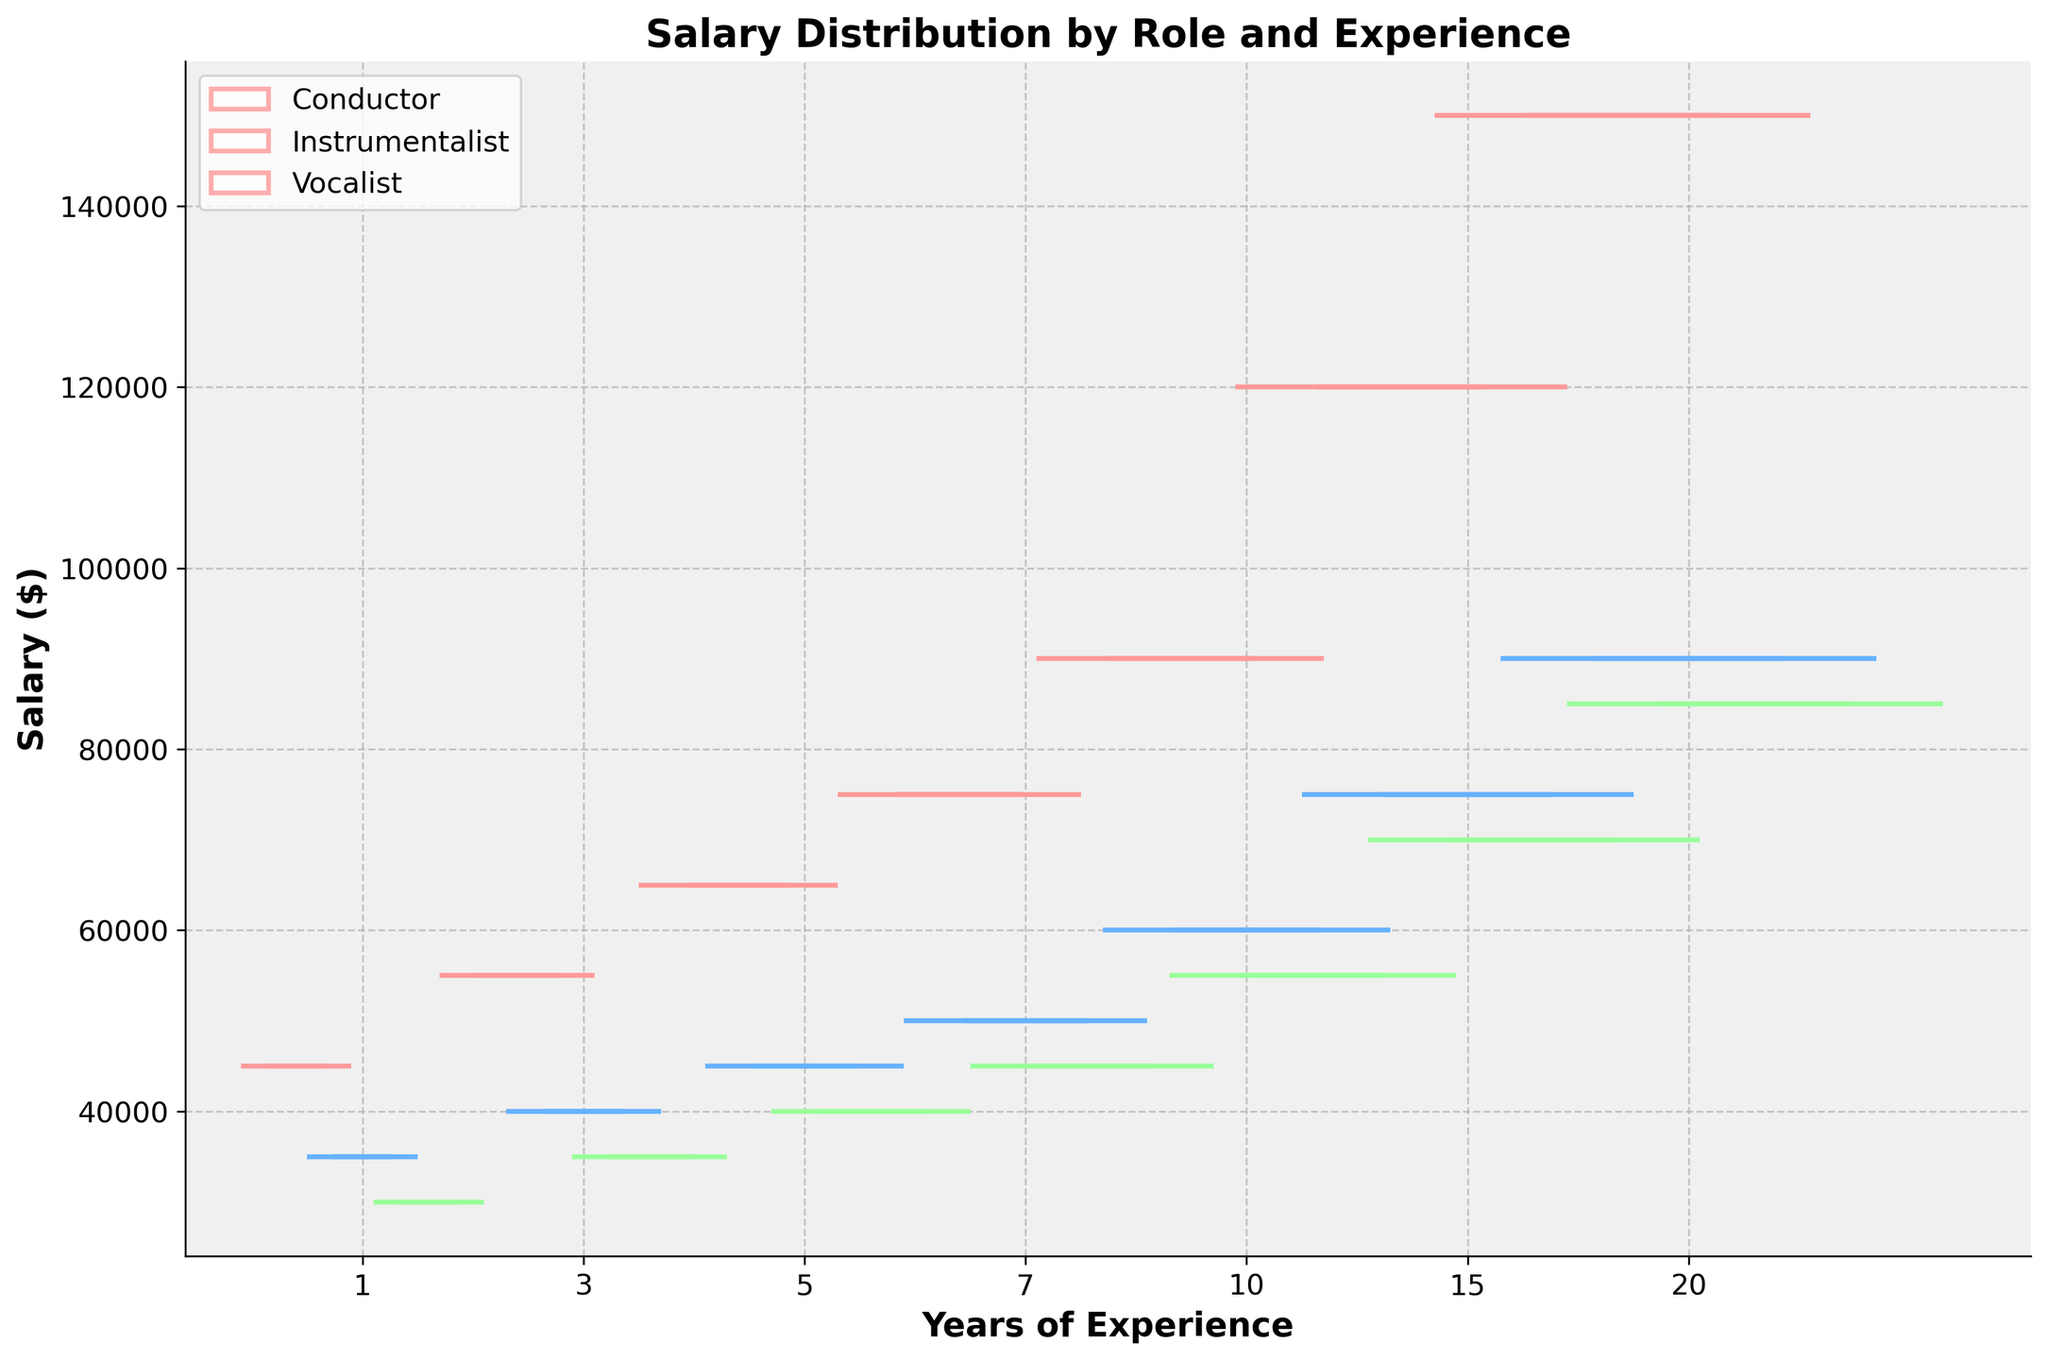What's the title of the figure? The title of the figure is written at the top and provides an overview of what the figure is about. By looking at the top of the figure, you can see the title clearly.
Answer: Salary Distribution by Role and Experience Which role has the highest median salary for 20 years of experience? To find the highest median salary for 20 years of experience, look at the boxes for each role at the 20-year mark. The one with the highest line in the middle of the box indicates the highest median salary.
Answer: Conductor What is the trend of the median salary for conductors as experience years increase? Observe the median lines (the horizontal lines inside the boxes) for conductors across different experience years. The trend shows how these medians change as the years of experience increase.
Answer: Increasing How does the salary range for vocalists compare at 10 and 15 years of experience? To compare the salary ranges, look at the box plots for vocalists at 10 and 15 years. The height of the boxes shows the range. A taller box means a wider range.
Answer: The range is wider at 15 years than at 10 years Which role shows the most significant increase in median salary from 1 year to 20 years of experience? For this, check the median lines for each role at 1 year and then at 20 years. Calculate the difference for each role and determine which has the largest increase.
Answer: Conductor How do the widths of the boxes change with experience years? The widths of the boxes represent the number of data points or variability. Look at how the widths vary as you move from 1 year to 20 years of experience to determine if they get wider or narrower.
Answer: Generally increase Which experience year has the most number of data points? The width of the box corresponds to the number of data points for that experience year. The year with the widest boxes has the most data points.
Answer: 20 years Do instrumentalists have a higher median salary than vocalists at 7 years of experience? Compare the medians (the lines inside the boxes) of the box plots for instrumentalists and vocalists at the 7-year mark to see which is higher.
Answer: Yes What is the color used for conductors in the figure? Each role in the figure is represented by a different color. By looking at the boxes for conductors, you can identify their color.
Answer: Red (or a similar shade) Are there any outliers shown in the box plots? Outliers are usually shown as points outside the main box and whiskers. Check the entire figure for any such points around the boxes and whiskers.
Answer: No 